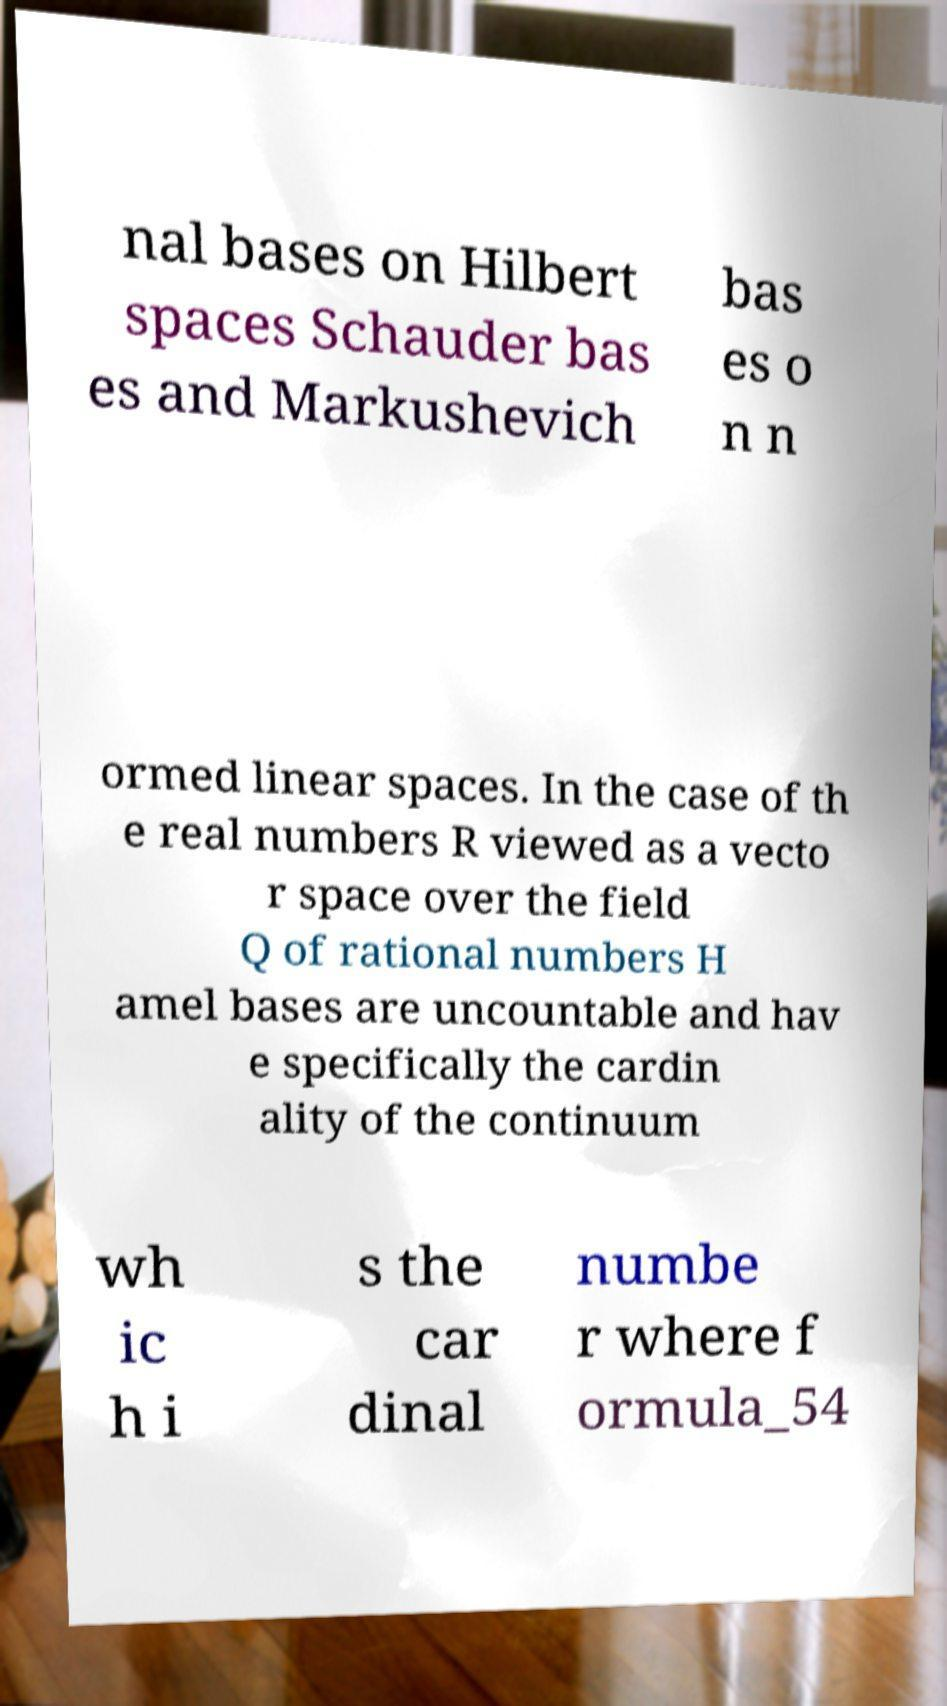I need the written content from this picture converted into text. Can you do that? nal bases on Hilbert spaces Schauder bas es and Markushevich bas es o n n ormed linear spaces. In the case of th e real numbers R viewed as a vecto r space over the field Q of rational numbers H amel bases are uncountable and hav e specifically the cardin ality of the continuum wh ic h i s the car dinal numbe r where f ormula_54 